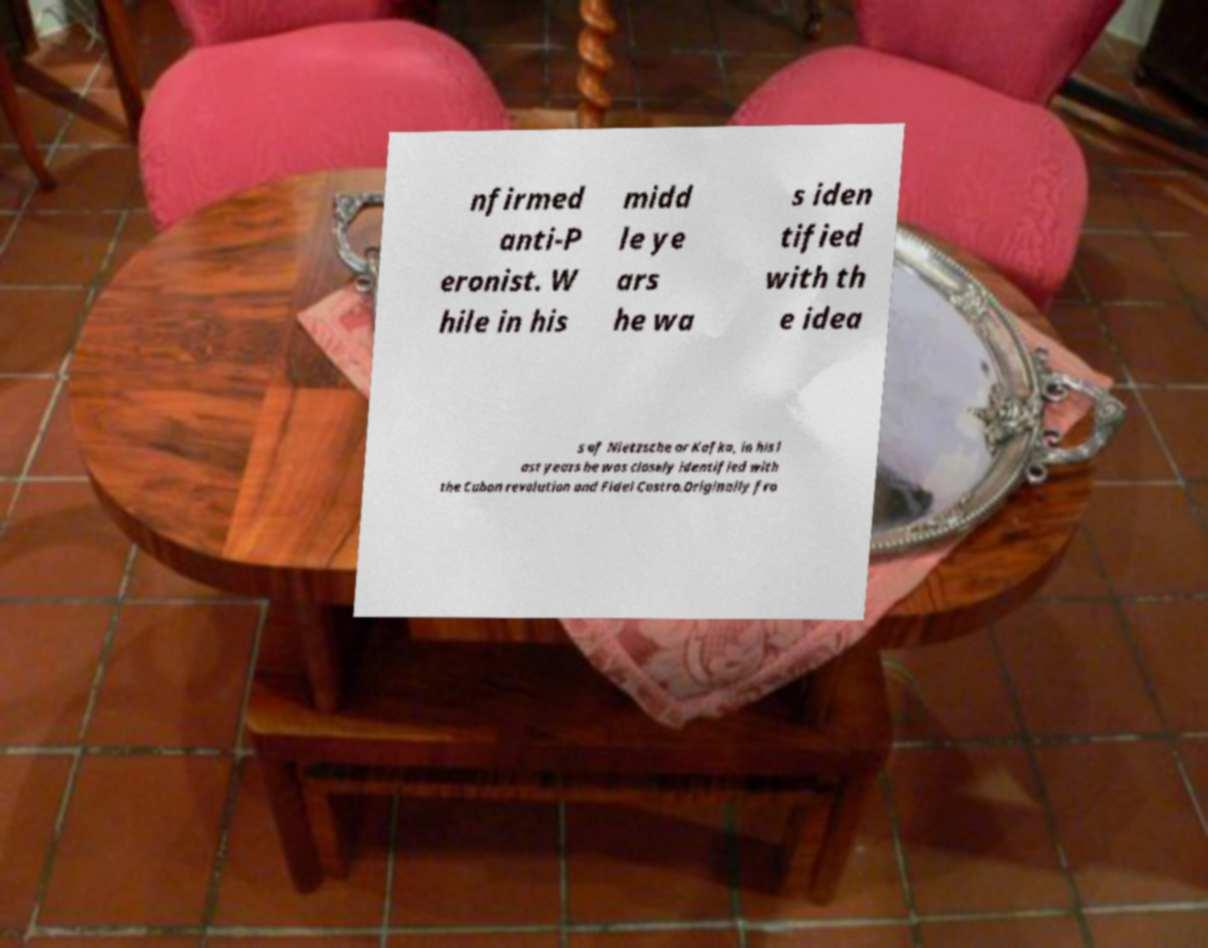Can you accurately transcribe the text from the provided image for me? nfirmed anti-P eronist. W hile in his midd le ye ars he wa s iden tified with th e idea s of Nietzsche or Kafka, in his l ast years he was closely identified with the Cuban revolution and Fidel Castro.Originally fro 